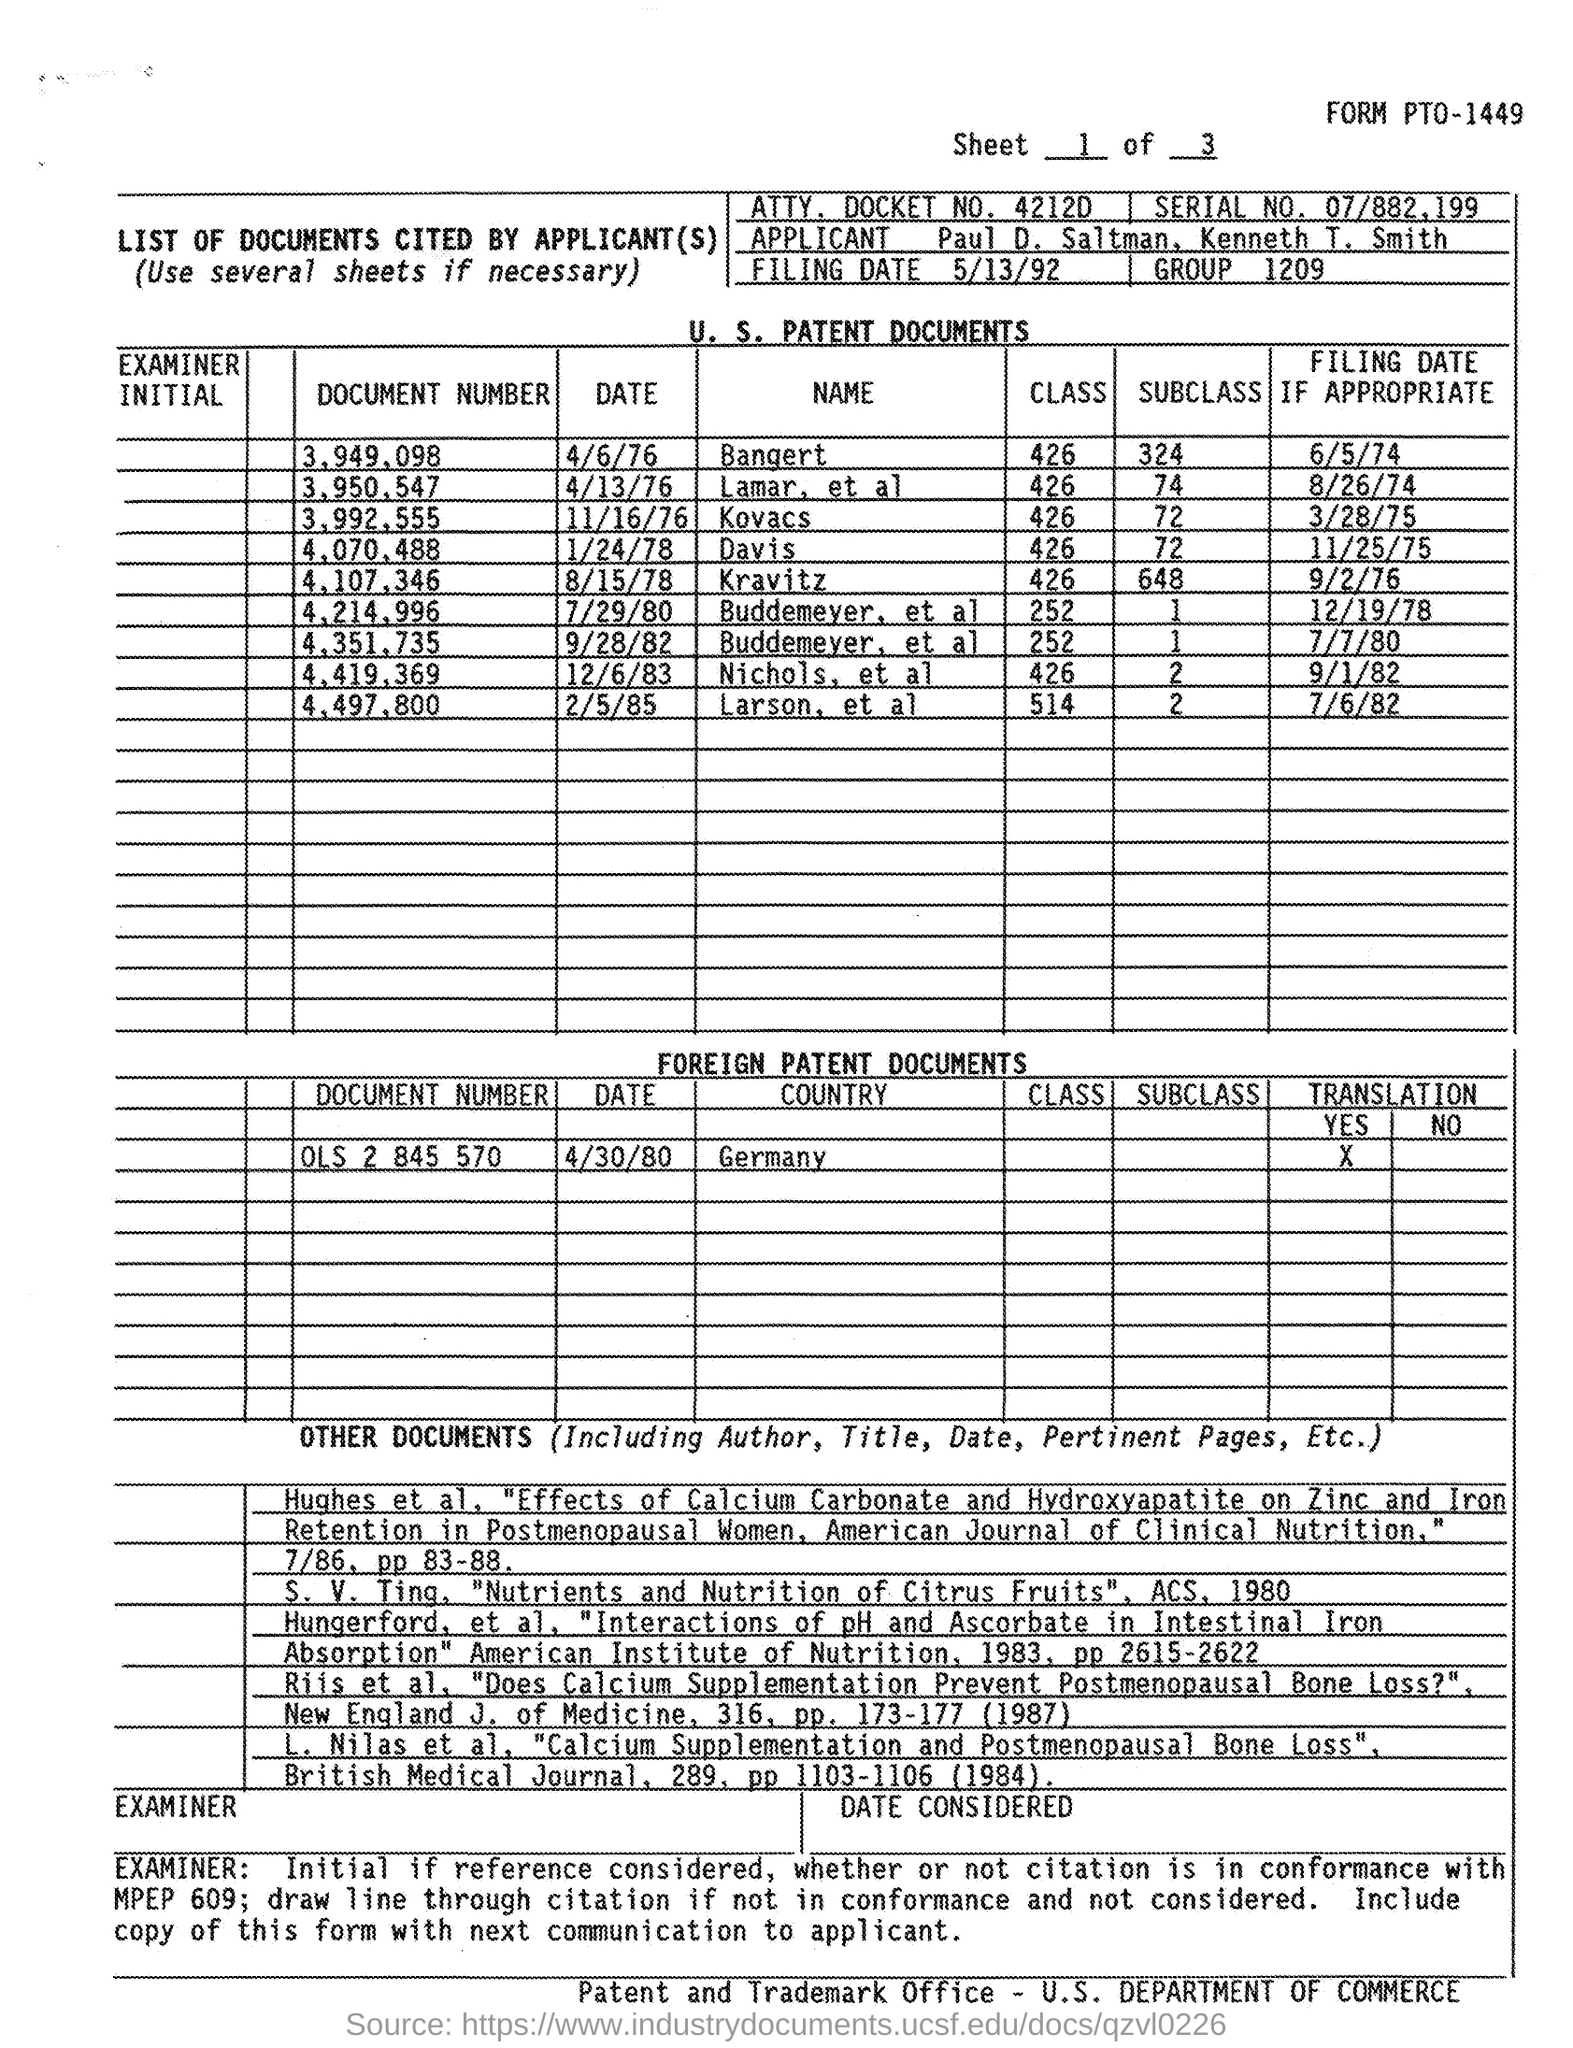What is the ATTY. DOCKET NO. given in the document?
Make the answer very short. 4212D. What is the Serial No mentioned in this document?
Provide a short and direct response. 07/882,199. What is the Document Number of Bangert given?
Keep it short and to the point. 3,949,098. What is the Document Number of Kovacs given?
Ensure brevity in your answer.  3,992,555. How many classes are mentioned for Davis as per the document?
Offer a very short reply. 426. How many Subclasses are mentioned for Kravitz as per the document?
Your answer should be very brief. 648. What is the filing date of the document number 3,949,098?
Give a very brief answer. 6/5/74. 